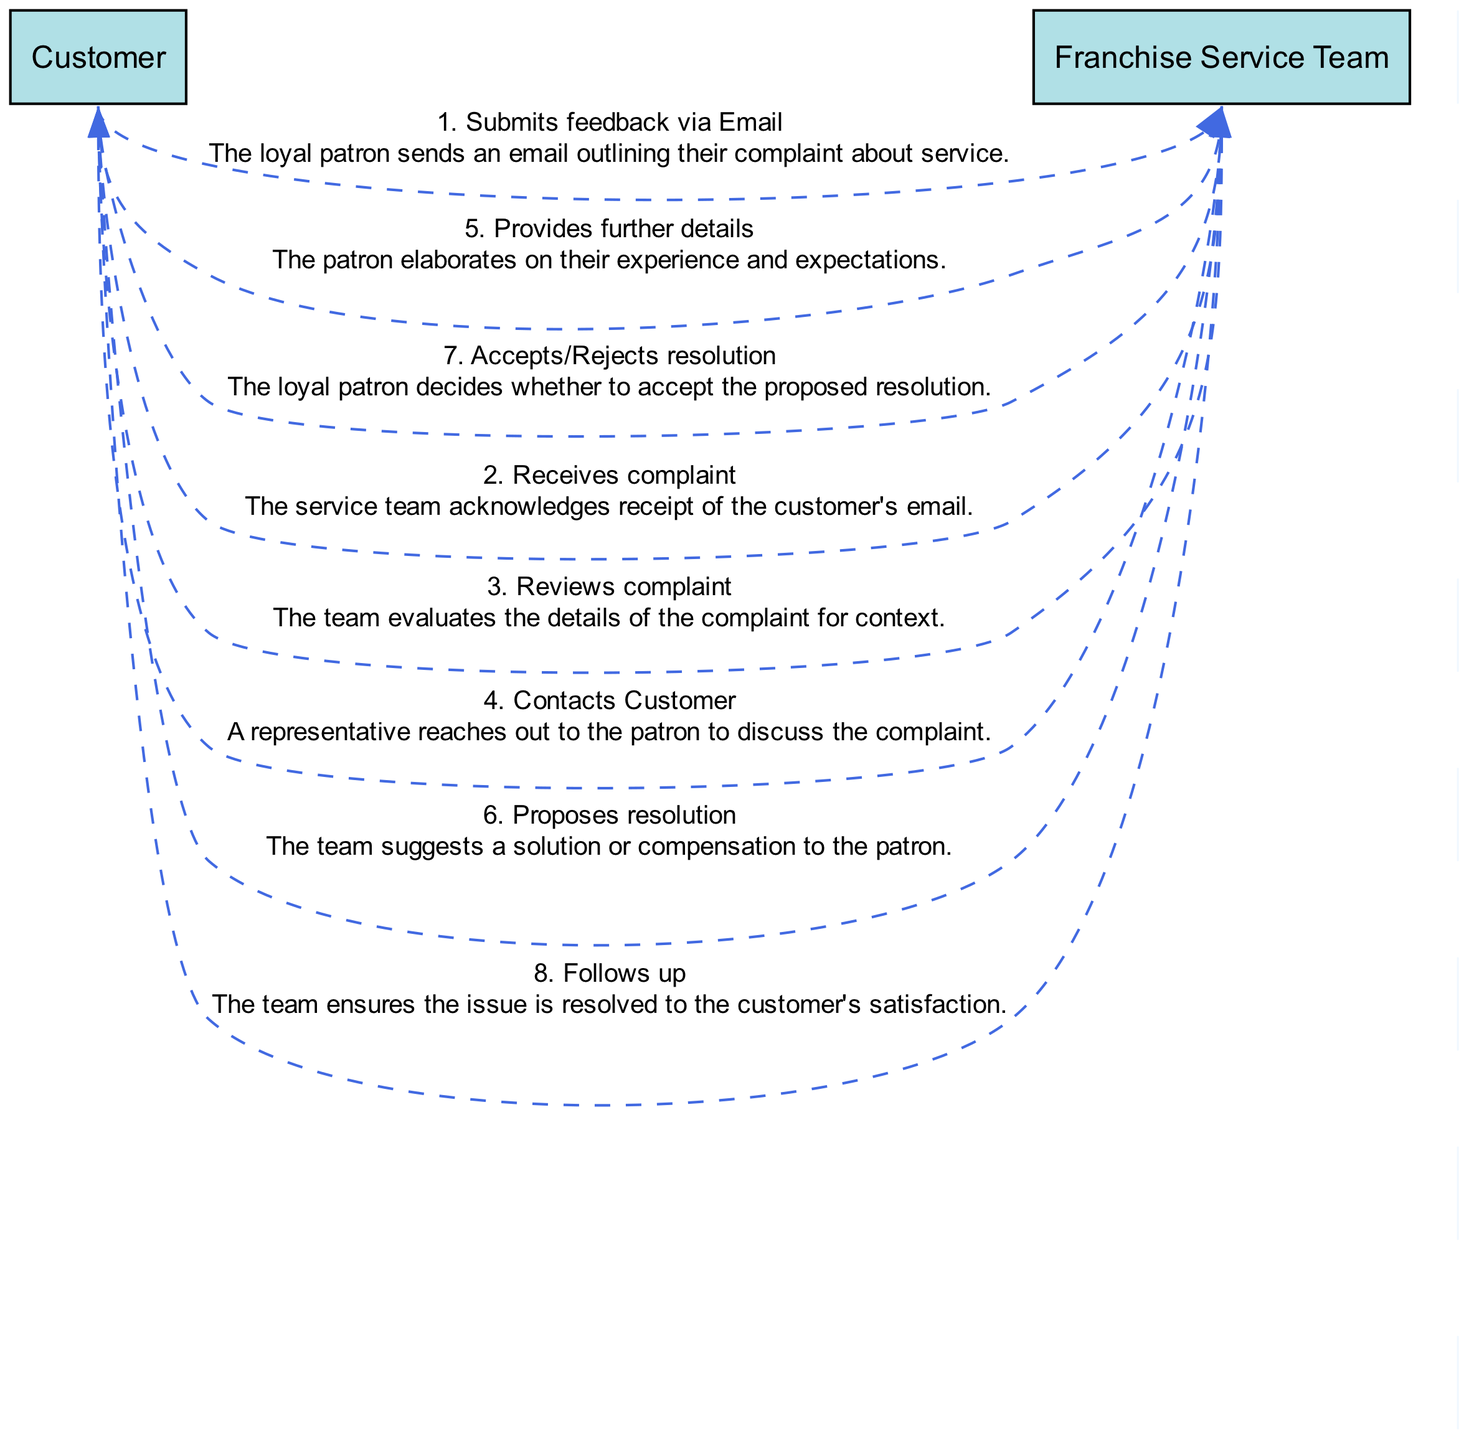What is the first action taken by the Customer? The first action shown in the diagram depicts the Customer submitting feedback via Email, which initiates the complaint process.
Answer: Submits feedback via Email How many actions are represented in the diagram? By counting each action listed in the sequence elements, there are a total of 8 actions depicted in the diagram.
Answer: 8 Which entity reviews the complaint? The sequence clearly indicates that the Franchise Service Team is responsible for reviewing the complaint after receiving it.
Answer: Franchise Service Team What is the last action in the sequence? The diagram indicates that the last action is a follow-up by the Franchise Service Team to ensure customer satisfaction after the resolution.
Answer: Follows up What does the customer do after the Franchise Service Team proposes a resolution? The diagram shows that after a resolution is proposed, the Customer makes a decision to either accept or reject the proposed resolution.
Answer: Accepts/Rejects resolution Which entities are involved in the interaction? The entities mentioned in the diagram include the Customer and the Franchise Service Team, both of which are active participants in the complaint resolution process.
Answer: Customer, Franchise Service Team How does the Franchise Service Team communicate with the Customer? The diagram illustrates that the Franchise Service Team contacts the Customer directly to discuss the complaint details, after receiving the initial feedback.
Answer: Contacts Customer What is the purpose of the follow-up action by the Franchise Service Team? The follow-up action is intended to ensure that the issue raised by the Customer is fully resolved and that the Customer is satisfied with the outcome of the complaint processing.
Answer: Ensures issue is resolved 